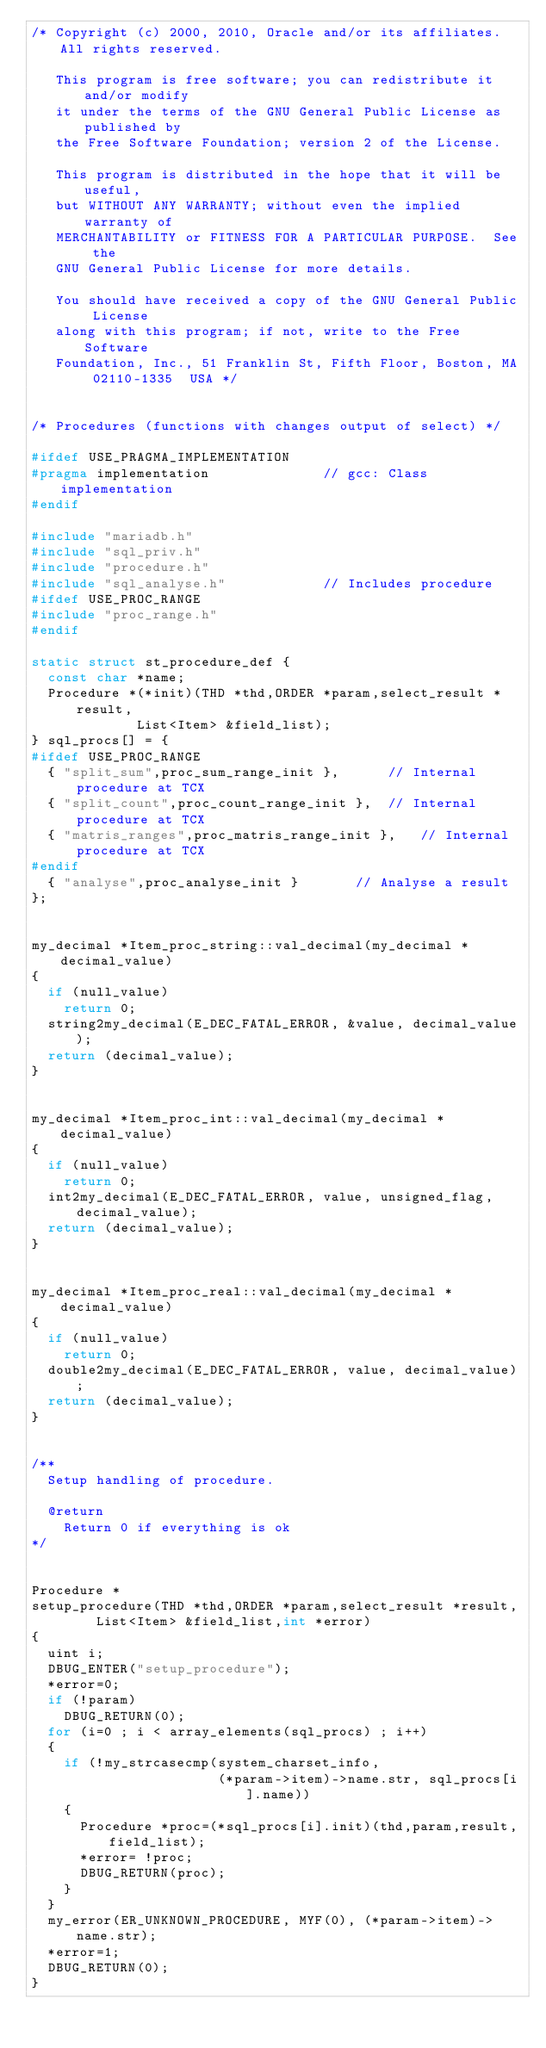<code> <loc_0><loc_0><loc_500><loc_500><_C++_>/* Copyright (c) 2000, 2010, Oracle and/or its affiliates. All rights reserved.

   This program is free software; you can redistribute it and/or modify
   it under the terms of the GNU General Public License as published by
   the Free Software Foundation; version 2 of the License.

   This program is distributed in the hope that it will be useful,
   but WITHOUT ANY WARRANTY; without even the implied warranty of
   MERCHANTABILITY or FITNESS FOR A PARTICULAR PURPOSE.  See the
   GNU General Public License for more details.

   You should have received a copy of the GNU General Public License
   along with this program; if not, write to the Free Software
   Foundation, Inc., 51 Franklin St, Fifth Floor, Boston, MA 02110-1335  USA */


/* Procedures (functions with changes output of select) */

#ifdef USE_PRAGMA_IMPLEMENTATION
#pragma implementation				// gcc: Class implementation
#endif

#include "mariadb.h"
#include "sql_priv.h"
#include "procedure.h"
#include "sql_analyse.h"			// Includes procedure
#ifdef USE_PROC_RANGE
#include "proc_range.h"
#endif

static struct st_procedure_def {
  const char *name;
  Procedure *(*init)(THD *thd,ORDER *param,select_result *result,
		     List<Item> &field_list);
} sql_procs[] = {
#ifdef USE_PROC_RANGE
  { "split_sum",proc_sum_range_init },		// Internal procedure at TCX
  { "split_count",proc_count_range_init },	// Internal procedure at TCX
  { "matris_ranges",proc_matris_range_init },	// Internal procedure at TCX
#endif
  { "analyse",proc_analyse_init }		// Analyse a result
};


my_decimal *Item_proc_string::val_decimal(my_decimal *decimal_value)
{
  if (null_value)
    return 0;
  string2my_decimal(E_DEC_FATAL_ERROR, &value, decimal_value);
  return (decimal_value);
}


my_decimal *Item_proc_int::val_decimal(my_decimal *decimal_value)
{
  if (null_value)
    return 0;
  int2my_decimal(E_DEC_FATAL_ERROR, value, unsigned_flag, decimal_value);
  return (decimal_value);
}


my_decimal *Item_proc_real::val_decimal(my_decimal *decimal_value)
{
  if (null_value)
    return 0;
  double2my_decimal(E_DEC_FATAL_ERROR, value, decimal_value);
  return (decimal_value);
}


/**
  Setup handling of procedure.

  @return
    Return 0 if everything is ok
*/


Procedure *
setup_procedure(THD *thd,ORDER *param,select_result *result,
		List<Item> &field_list,int *error)
{
  uint i;
  DBUG_ENTER("setup_procedure");
  *error=0;
  if (!param)
    DBUG_RETURN(0);
  for (i=0 ; i < array_elements(sql_procs) ; i++)
  {
    if (!my_strcasecmp(system_charset_info,
                       (*param->item)->name.str, sql_procs[i].name))
    {
      Procedure *proc=(*sql_procs[i].init)(thd,param,result,field_list);
      *error= !proc;
      DBUG_RETURN(proc);
    }
  }
  my_error(ER_UNKNOWN_PROCEDURE, MYF(0), (*param->item)->name.str);
  *error=1;
  DBUG_RETURN(0);
}
</code> 